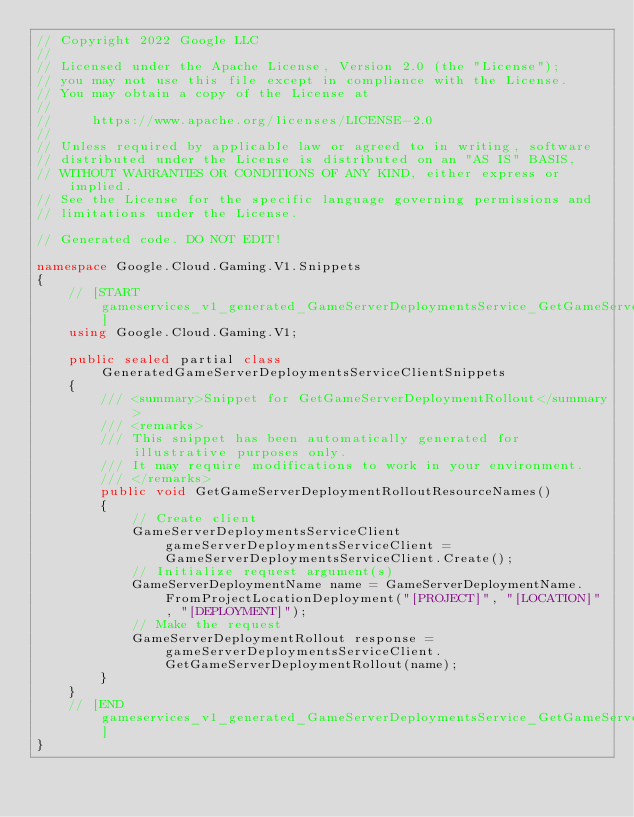<code> <loc_0><loc_0><loc_500><loc_500><_C#_>// Copyright 2022 Google LLC
//
// Licensed under the Apache License, Version 2.0 (the "License");
// you may not use this file except in compliance with the License.
// You may obtain a copy of the License at
//
//     https://www.apache.org/licenses/LICENSE-2.0
//
// Unless required by applicable law or agreed to in writing, software
// distributed under the License is distributed on an "AS IS" BASIS,
// WITHOUT WARRANTIES OR CONDITIONS OF ANY KIND, either express or implied.
// See the License for the specific language governing permissions and
// limitations under the License.

// Generated code. DO NOT EDIT!

namespace Google.Cloud.Gaming.V1.Snippets
{
    // [START gameservices_v1_generated_GameServerDeploymentsService_GetGameServerDeploymentRollout_sync_flattened_resourceNames]
    using Google.Cloud.Gaming.V1;

    public sealed partial class GeneratedGameServerDeploymentsServiceClientSnippets
    {
        /// <summary>Snippet for GetGameServerDeploymentRollout</summary>
        /// <remarks>
        /// This snippet has been automatically generated for illustrative purposes only.
        /// It may require modifications to work in your environment.
        /// </remarks>
        public void GetGameServerDeploymentRolloutResourceNames()
        {
            // Create client
            GameServerDeploymentsServiceClient gameServerDeploymentsServiceClient = GameServerDeploymentsServiceClient.Create();
            // Initialize request argument(s)
            GameServerDeploymentName name = GameServerDeploymentName.FromProjectLocationDeployment("[PROJECT]", "[LOCATION]", "[DEPLOYMENT]");
            // Make the request
            GameServerDeploymentRollout response = gameServerDeploymentsServiceClient.GetGameServerDeploymentRollout(name);
        }
    }
    // [END gameservices_v1_generated_GameServerDeploymentsService_GetGameServerDeploymentRollout_sync_flattened_resourceNames]
}
</code> 